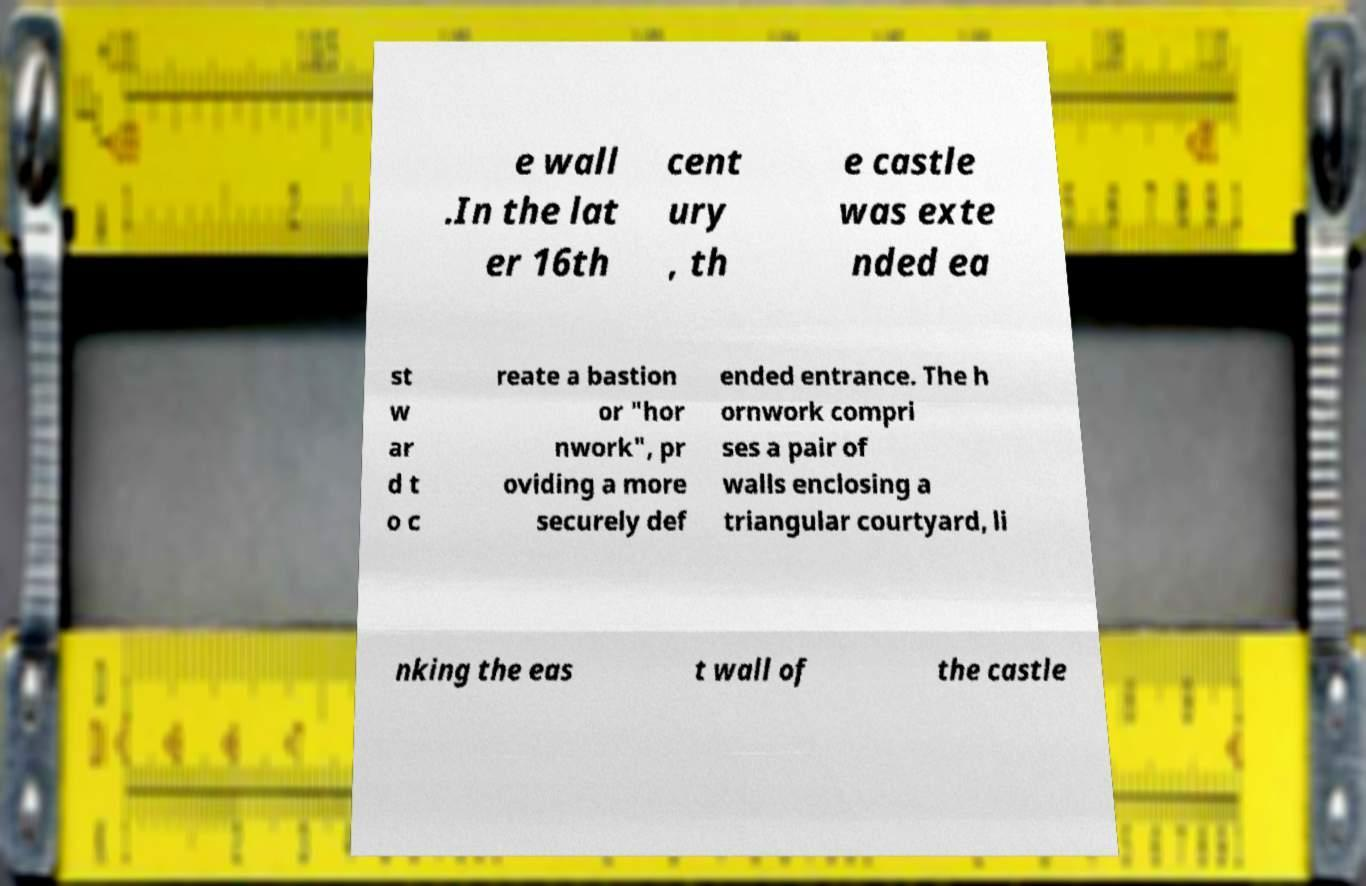Can you read and provide the text displayed in the image?This photo seems to have some interesting text. Can you extract and type it out for me? e wall .In the lat er 16th cent ury , th e castle was exte nded ea st w ar d t o c reate a bastion or "hor nwork", pr oviding a more securely def ended entrance. The h ornwork compri ses a pair of walls enclosing a triangular courtyard, li nking the eas t wall of the castle 